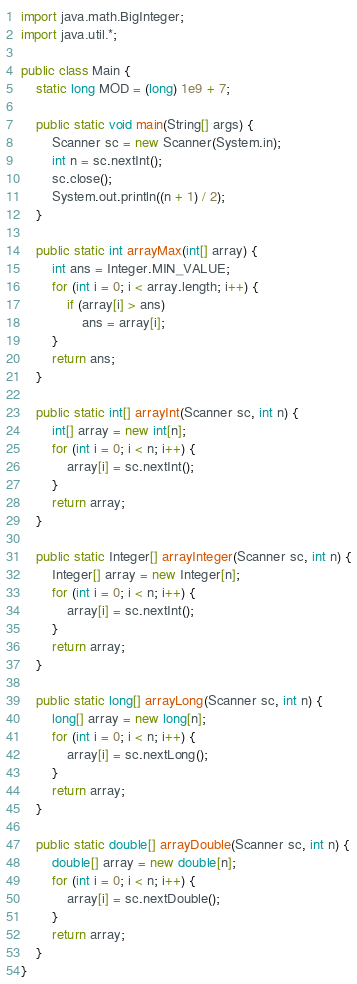<code> <loc_0><loc_0><loc_500><loc_500><_Java_>import java.math.BigInteger;
import java.util.*;

public class Main {
	static long MOD = (long) 1e9 + 7;

	public static void main(String[] args) {
		Scanner sc = new Scanner(System.in);
		int n = sc.nextInt();
		sc.close();
		System.out.println((n + 1) / 2);
	}

	public static int arrayMax(int[] array) {
		int ans = Integer.MIN_VALUE;
		for (int i = 0; i < array.length; i++) {
			if (array[i] > ans)
				ans = array[i];
		}
		return ans;
	}

	public static int[] arrayInt(Scanner sc, int n) {
		int[] array = new int[n];
		for (int i = 0; i < n; i++) {
			array[i] = sc.nextInt();
		}
		return array;
	}

	public static Integer[] arrayInteger(Scanner sc, int n) {
		Integer[] array = new Integer[n];
		for (int i = 0; i < n; i++) {
			array[i] = sc.nextInt();
		}
		return array;
	}

	public static long[] arrayLong(Scanner sc, int n) {
		long[] array = new long[n];
		for (int i = 0; i < n; i++) {
			array[i] = sc.nextLong();
		}
		return array;
	}

	public static double[] arrayDouble(Scanner sc, int n) {
		double[] array = new double[n];
		for (int i = 0; i < n; i++) {
			array[i] = sc.nextDouble();
		}
		return array;
	}
}
</code> 